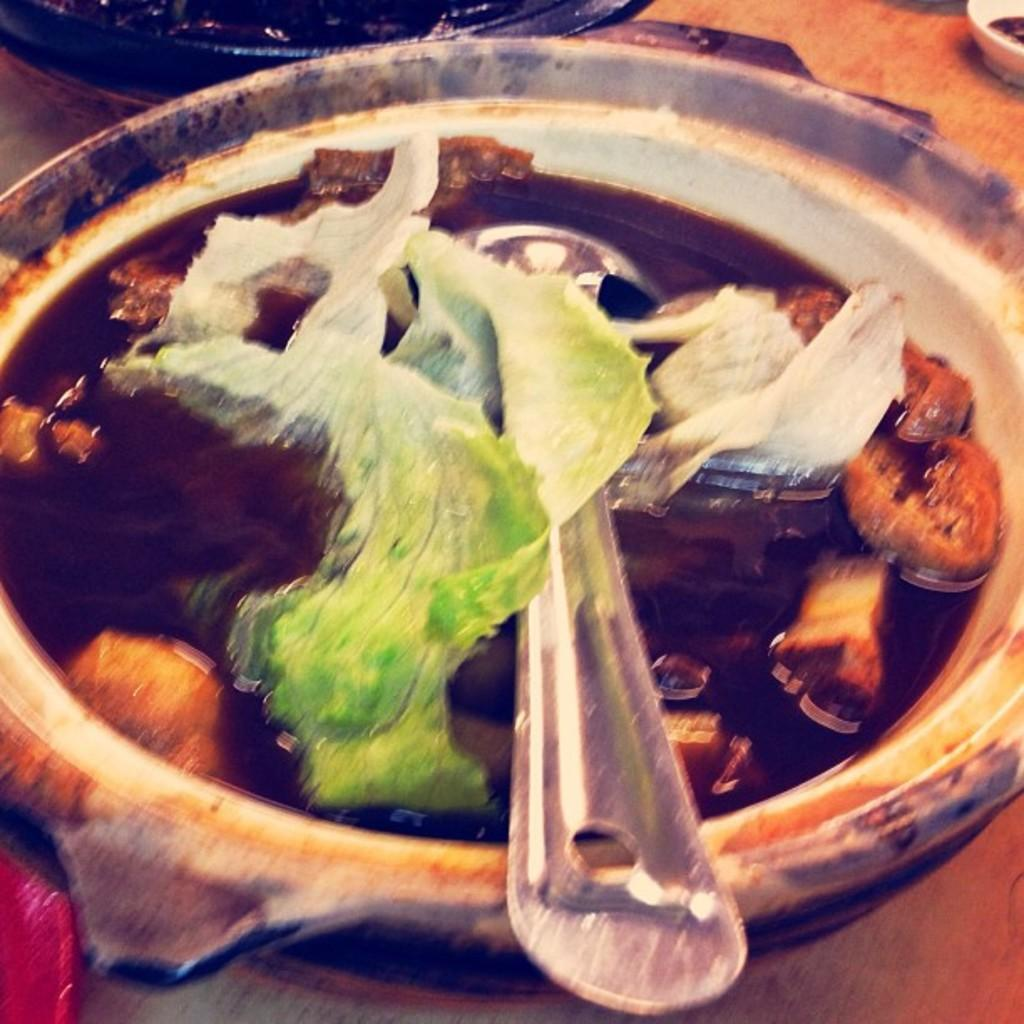What type of food can be seen in the image? The food in the image has green and brown colors. How is the food being served? The food is in a bowl. What utensil is present in the image? There is a spoon visible in the image. How many fish can be seen swimming in the bowl in the image? There are no fish present in the image; it features food in a bowl with a spoon. What type of calendar is hanging on the wall in the image? There is no calendar visible in the image. 